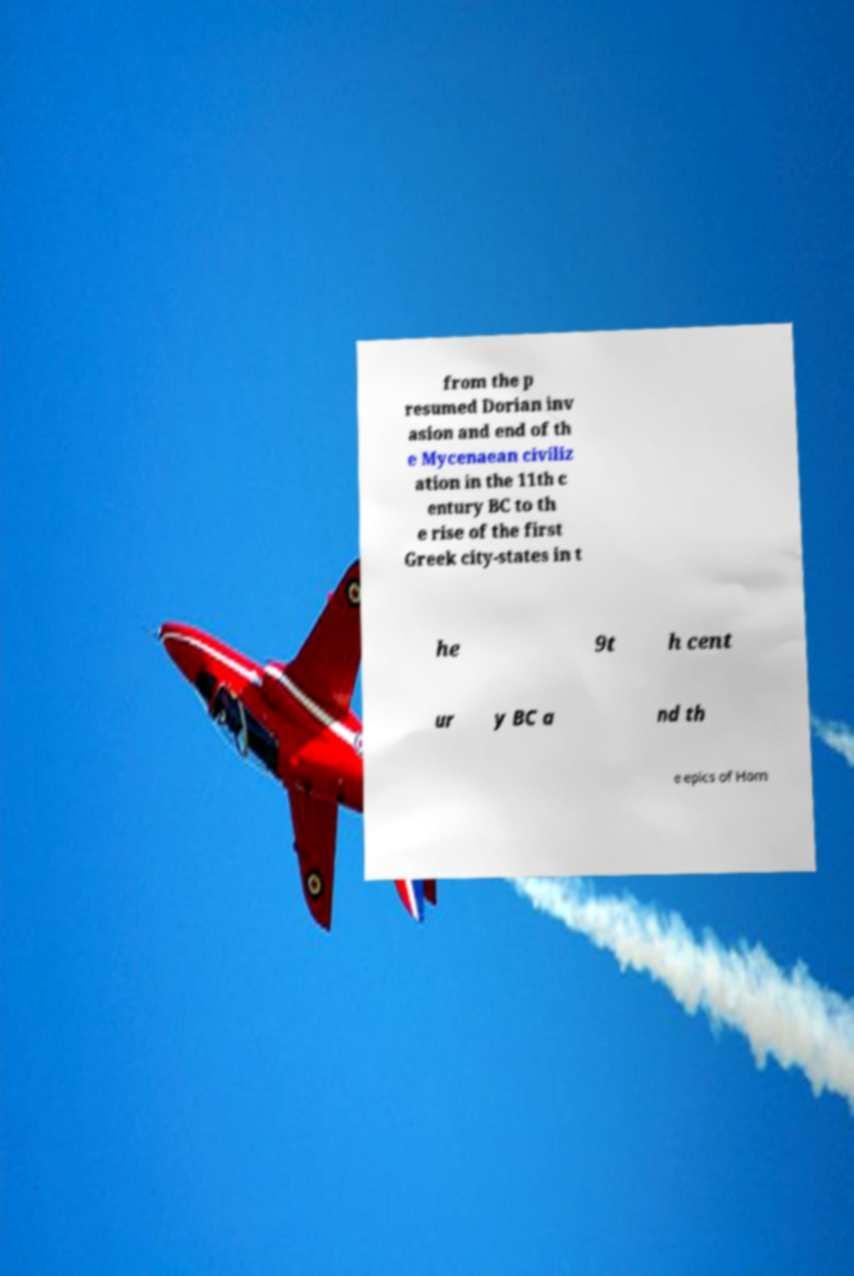There's text embedded in this image that I need extracted. Can you transcribe it verbatim? from the p resumed Dorian inv asion and end of th e Mycenaean civiliz ation in the 11th c entury BC to th e rise of the first Greek city-states in t he 9t h cent ur y BC a nd th e epics of Hom 